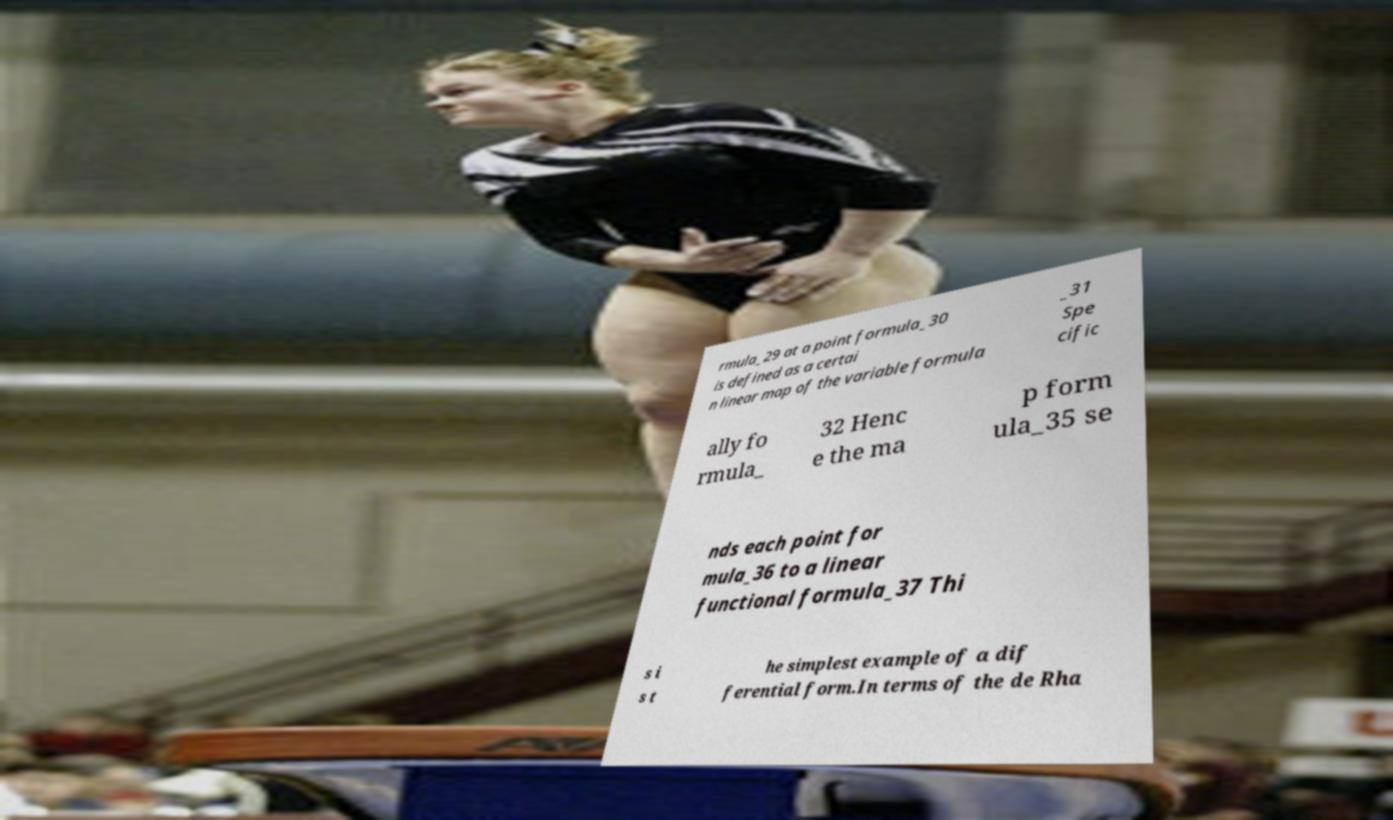There's text embedded in this image that I need extracted. Can you transcribe it verbatim? rmula_29 at a point formula_30 is defined as a certai n linear map of the variable formula _31 Spe cific ally fo rmula_ 32 Henc e the ma p form ula_35 se nds each point for mula_36 to a linear functional formula_37 Thi s i s t he simplest example of a dif ferential form.In terms of the de Rha 